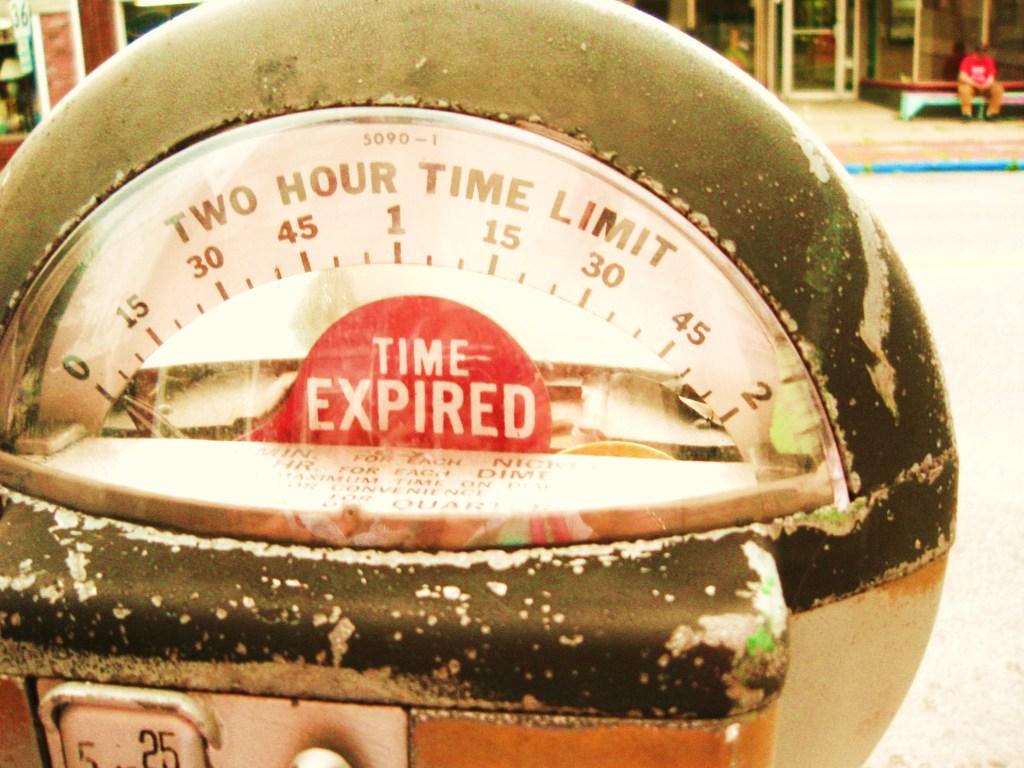What is the max time before meter expires?
Ensure brevity in your answer.  2 hours. What does the letters on top say'?
Your answer should be very brief. Two hour time limit. 